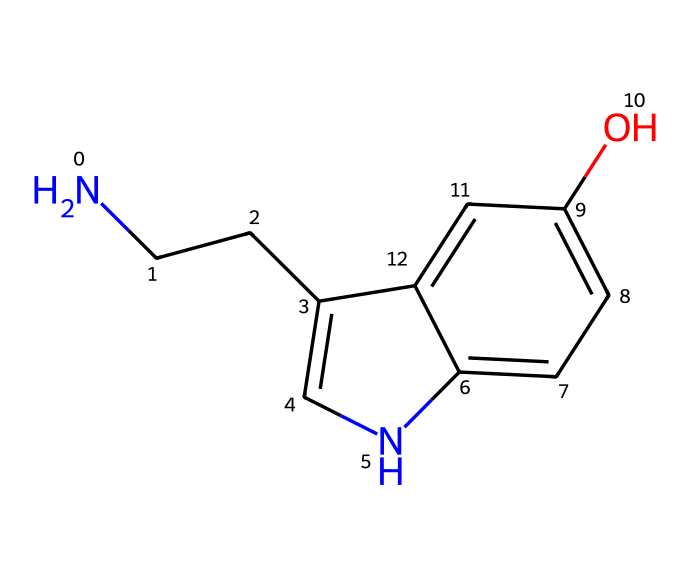What is the molecular formula of this chemical? To determine the molecular formula, we need to count the number of each atom present in the structure derived from the SMILES notation. The atoms in the structure are: 2 Nitrogen (N), 10 Carbon (C), 12 Hydrogen (H), and 1 Oxygen (O). Hence, the molecular formula is C10H12N2O.
Answer: C10H12N2O How many rings are present in the structure? By analyzing the chemical structure from the SMILES notation, we can identify that there are two ring structures in the molecule. The presence of cycled carbon atoms indicates rings are present.
Answer: 2 What is the role of the hydroxyl group in this chemical? The hydroxyl (–OH) group in this molecule, indicated by the O in the formula, contributes to its polar nature and enhances its ability to form hydrogen bonds, which can affect the molecule's solubility and interactions with receptors.
Answer: polar Which atom is responsible for nitrogen's basicity? The nitrogen atom in this chemical exhibits basicity primarily due to the electron pair on its nitrogen atom which can accept protons, making it act as a base. In the context of this SMILES structure, there are two nitrogen atoms and at least one shows this characteristic.
Answer: nitrogen How does this chemical influence mood regulation? This chemical, serotonin, acts as a neurotransmitter in the brain and plays a pivotal role in regulating mood, emotion, and happiness. Its balance and levels impact psychological well-being and mood disorders.
Answer: neurotransmitter 